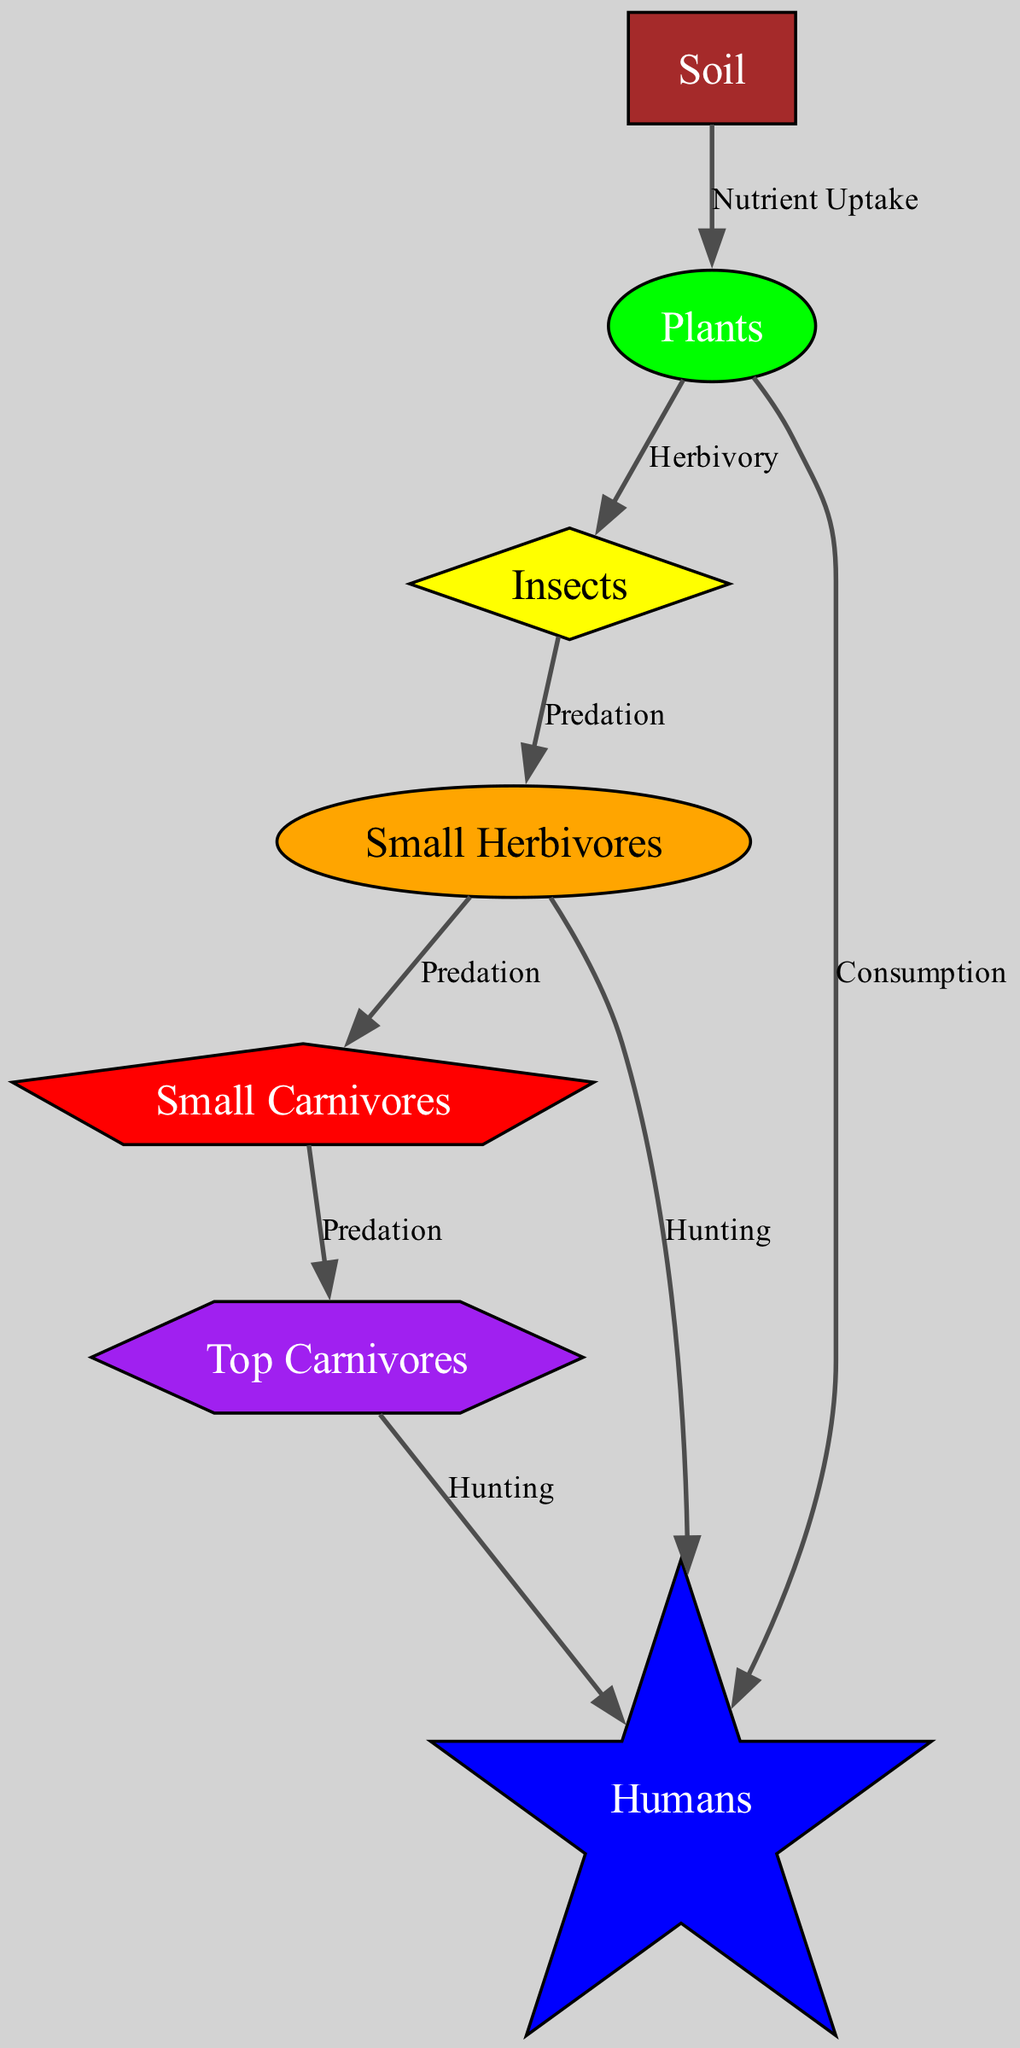What are the two pathways leading from plants? The diagram shows two outgoing edges from the 'plants' node: one to 'insects' labeled 'Herbivory' and another to 'humans' labeled 'Consumption.'
Answer: insects and humans How many nodes are there in total in the diagram? Counting the unique identifiers for the nodes, there are a total of seven nodes: soil, plants, insects, small herbivores, small carnivores, top carnivores, and humans.
Answer: 7 Which node has a relationship of predation with small herbivores? Referring to the edges, there is one directed edge leading from 'small herbivores' to 'small carnivores' indicating that small carnivores predate on small herbivores.
Answer: small carnivores What type of relationship do insects have with plants? The edge connecting 'plants' to 'insects' shows the relationship is labeled 'Herbivory,' which indicates that insects consume plants.
Answer: Herbivory What is the last node that is connected to humans in the food chain? Tracing the outgoing edges from 'humans', the last node leading to humans is 'top carnivores' through a hunting relationship.
Answer: top carnivores How many predation relationships are displayed in the food chain diagram? By analyzing the edges labeled with 'Predation', there are three predation relationships represented in the diagram: insects to small herbivores, small herbivores to small carnivores, and small carnivores to top carnivores.
Answer: 3 What color represents the 'small carnivores' node? The diagram specifies that the 'small carnivores' node is filled with red color according to the defined node styles.
Answer: red What is the relationship between soil and plants? The edge from 'soil' to 'plants' is labeled 'Nutrient Uptake', indicating that soil provides nutrients to the plants.
Answer: Nutrient Uptake Which node is the primary source of nutrients in the food chain? Analyzing the diagram, soil serves as the primary source of nutrients as it is the initial node from which plants obtain their nutrients.
Answer: soil 